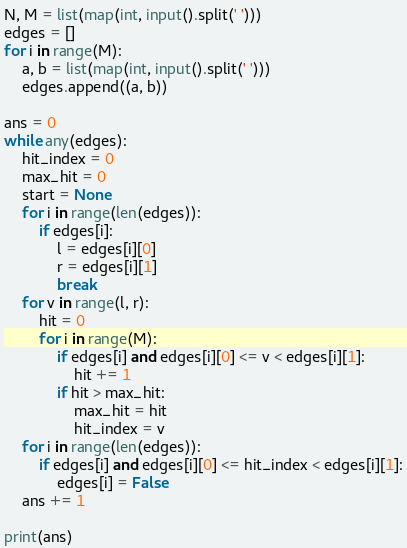Convert code to text. <code><loc_0><loc_0><loc_500><loc_500><_Python_>N, M = list(map(int, input().split(' ')))
edges = []
for i in range(M):
    a, b = list(map(int, input().split(' ')))
    edges.append((a, b))
 
ans = 0
while any(edges):
    hit_index = 0
    max_hit = 0
    start = None
    for i in range(len(edges)):
        if edges[i]:
            l = edges[i][0]
            r = edges[i][1]
            break
    for v in range(l, r):
        hit = 0
        for i in range(M):
            if edges[i] and edges[i][0] <= v < edges[i][1]:
                hit += 1
            if hit > max_hit:
                max_hit = hit
                hit_index = v
    for i in range(len(edges)):
        if edges[i] and edges[i][0] <= hit_index < edges[i][1]:
            edges[i] = False
    ans += 1

print(ans)
</code> 